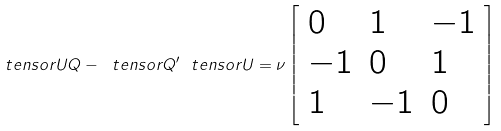<formula> <loc_0><loc_0><loc_500><loc_500>\ t e n s o r { U Q } - \ t e n s o r { Q } ^ { \prime } \ t e n s o r { U } = \nu \left [ \begin{array} { l l l } 0 & 1 & - 1 \\ - 1 & 0 & 1 \\ 1 & - 1 & 0 \end{array} \right ]</formula> 